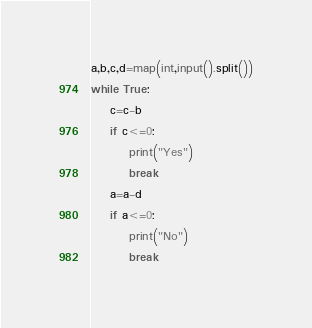Convert code to text. <code><loc_0><loc_0><loc_500><loc_500><_Python_>a,b,c,d=map(int,input().split())
while True:
    c=c-b
    if c<=0:
        print("Yes")
        break
    a=a-d
    if a<=0:
        print("No")
        break</code> 